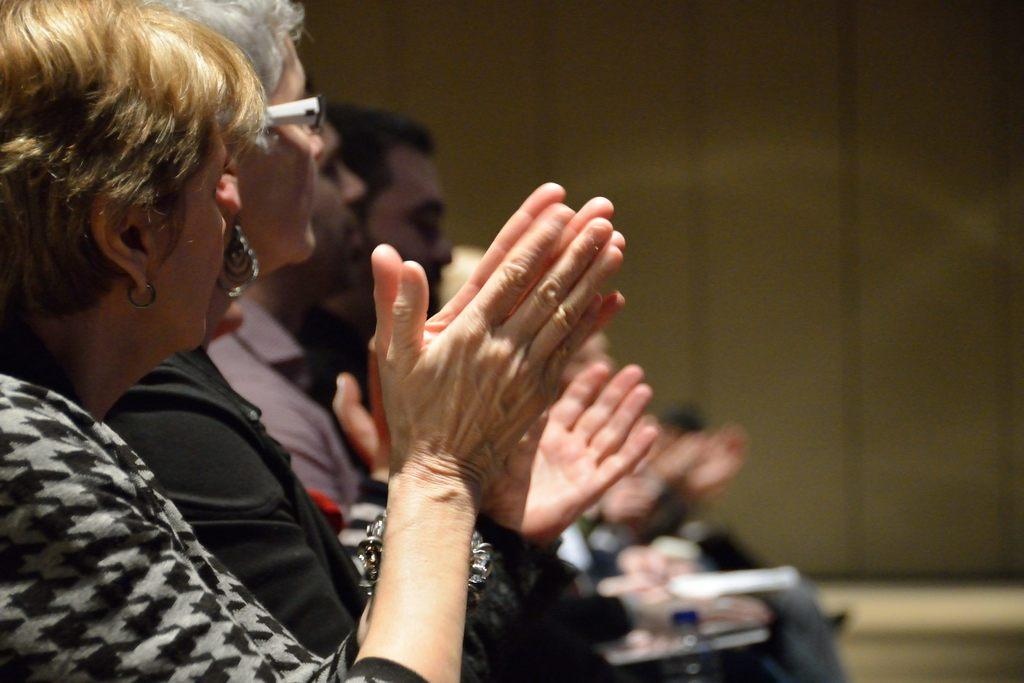How many people are present in the image? There are people in the image, but the exact number is not specified. Can you describe any specific features of one of the people? One person is wearing glasses (specs). What can be observed about the quality of the image in the background? The image is blurry in the background. What type of flag is being waved by the stranger in the image? There is no stranger or flag present in the image. Can you describe the family dynamics in the image? The facts provided do not mention any family members or dynamics. 